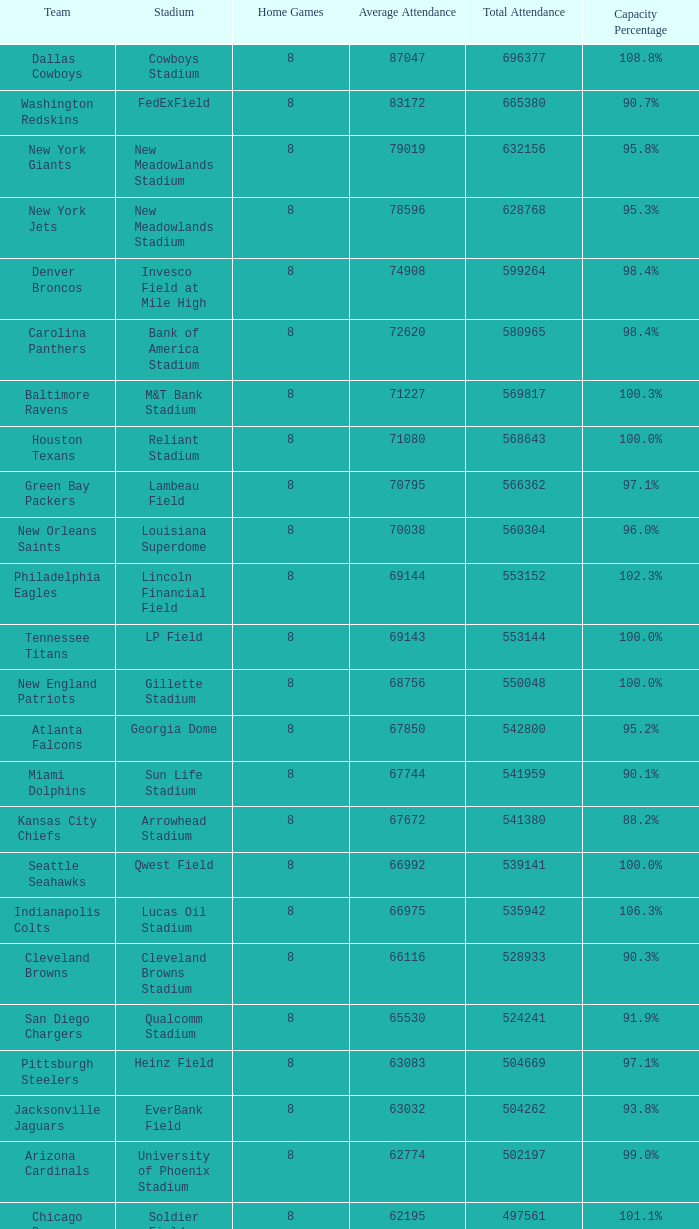What number of teams possessed a capacity rating of 99.3%? 1.0. 